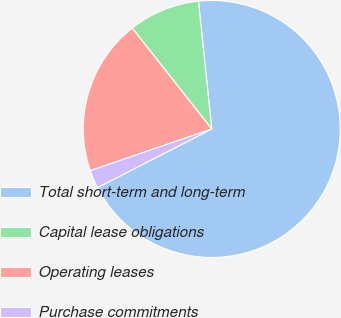Convert chart to OTSL. <chart><loc_0><loc_0><loc_500><loc_500><pie_chart><fcel>Total short-term and long-term<fcel>Capital lease obligations<fcel>Operating leases<fcel>Purchase commitments<nl><fcel>69.11%<fcel>8.97%<fcel>19.64%<fcel>2.28%<nl></chart> 